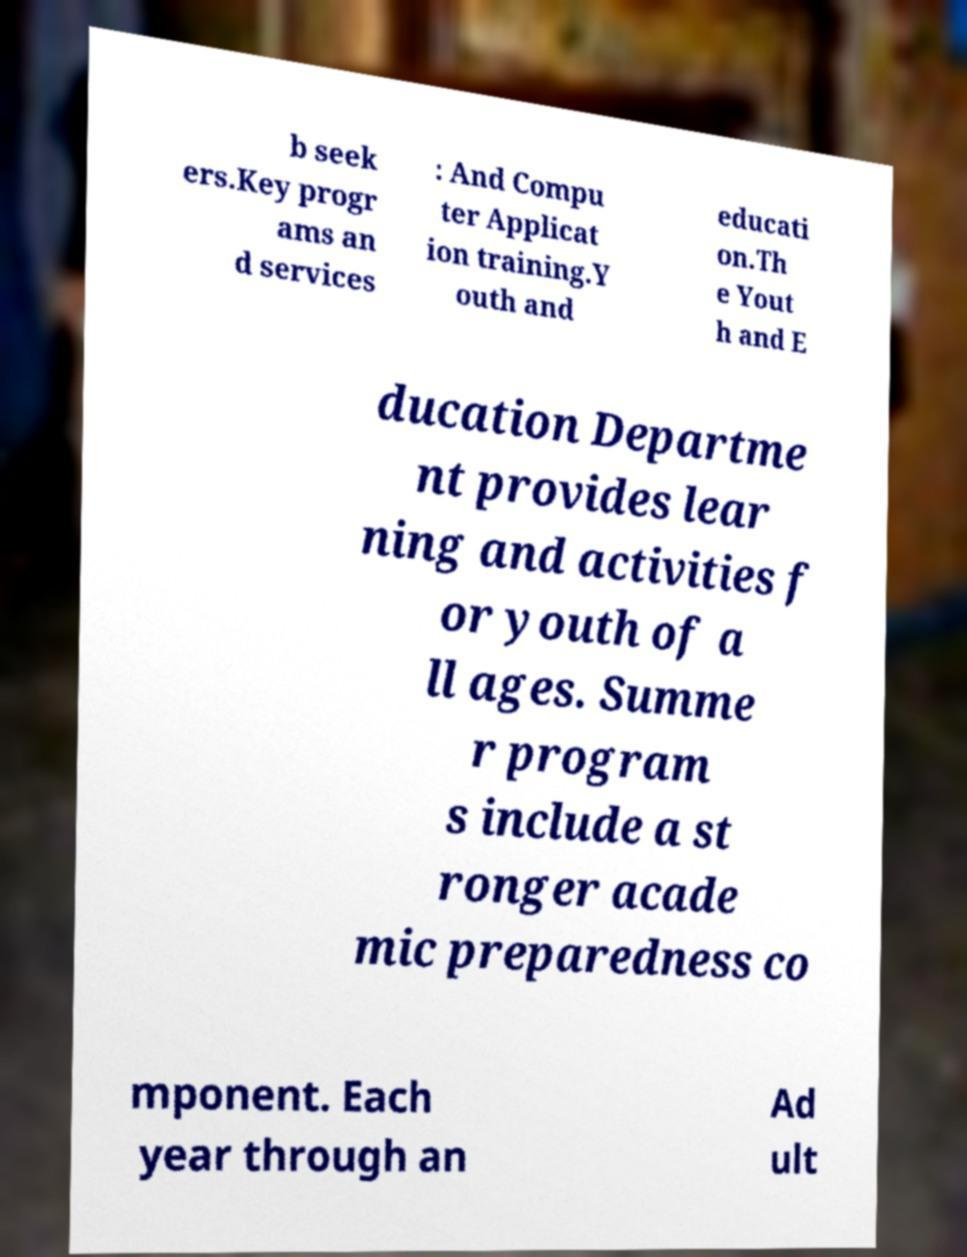I need the written content from this picture converted into text. Can you do that? b seek ers.Key progr ams an d services : And Compu ter Applicat ion training.Y outh and educati on.Th e Yout h and E ducation Departme nt provides lear ning and activities f or youth of a ll ages. Summe r program s include a st ronger acade mic preparedness co mponent. Each year through an Ad ult 